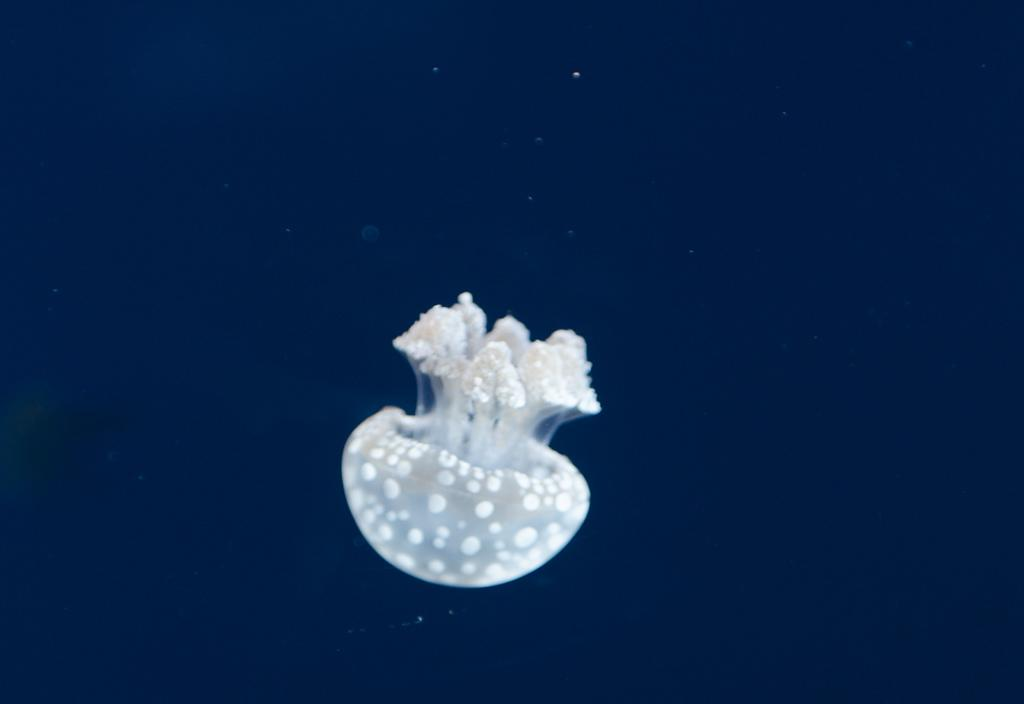What type of animal can be seen in the image? There is an aquatic animal in the image. What color is the background of the image? The background of the image is navy-blue in color. Can you tell me how many pigs are playing in the park in the image? There are no pigs or park present in the image; it features an aquatic animal with a navy-blue background. 